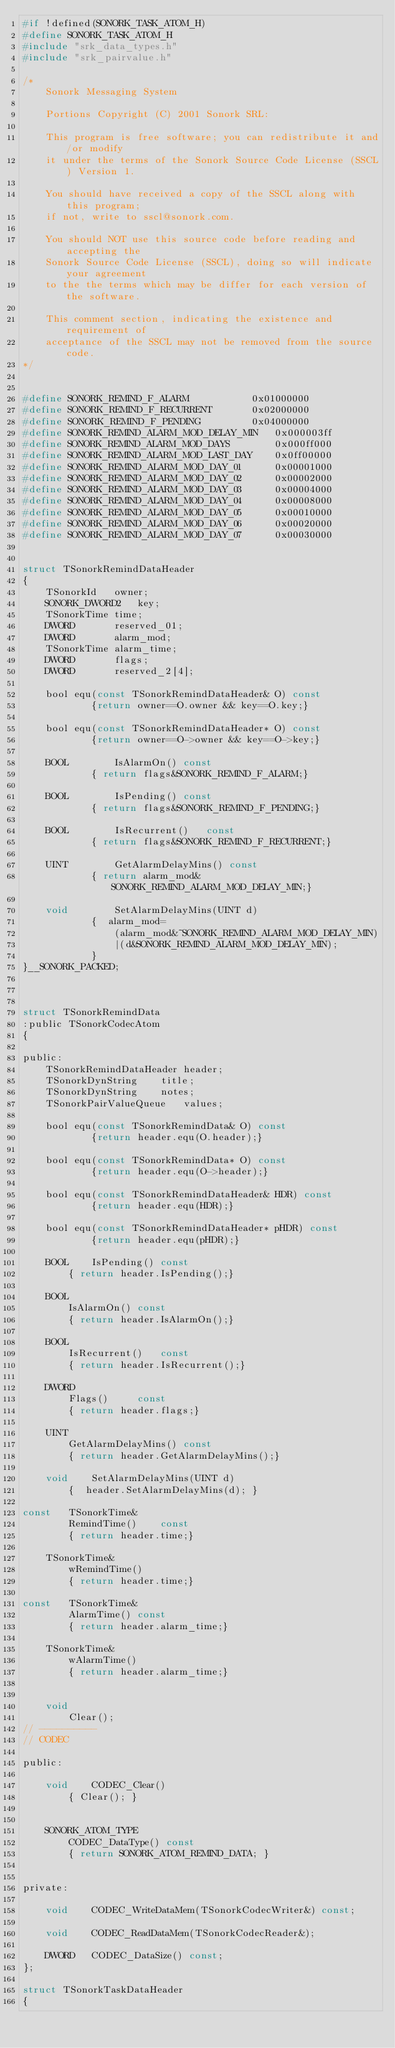Convert code to text. <code><loc_0><loc_0><loc_500><loc_500><_C_>#if !defined(SONORK_TASK_ATOM_H)
#define SONORK_TASK_ATOM_H
#include "srk_data_types.h"
#include "srk_pairvalue.h"

/*
	Sonork Messaging System

	Portions Copyright (C) 2001 Sonork SRL:

	This program is free software; you can redistribute it and/or modify
	it under the terms of the Sonork Source Code License (SSCL) Version 1.

	You should have received a copy of the SSCL	along with this program;
	if not, write to sscl@sonork.com.

	You should NOT use this source code before reading and accepting the
	Sonork Source Code License (SSCL), doing so will indicate your agreement
	to the the terms which may be differ for each version of the software.

	This comment section, indicating the existence and requirement of
	acceptance of the SSCL may not be removed from the source code.
*/


#define SONORK_REMIND_F_ALARM			0x01000000
#define SONORK_REMIND_F_RECURRENT		0x02000000
#define SONORK_REMIND_F_PENDING			0x04000000
#define SONORK_REMIND_ALARM_MOD_DELAY_MIN	0x000003ff
#define SONORK_REMIND_ALARM_MOD_DAYS   		0x000ff000
#define SONORK_REMIND_ALARM_MOD_LAST_DAY	0x0ff00000
#define SONORK_REMIND_ALARM_MOD_DAY_01		0x00001000
#define SONORK_REMIND_ALARM_MOD_DAY_02		0x00002000
#define SONORK_REMIND_ALARM_MOD_DAY_03		0x00004000
#define SONORK_REMIND_ALARM_MOD_DAY_04		0x00008000
#define SONORK_REMIND_ALARM_MOD_DAY_05		0x00010000
#define SONORK_REMIND_ALARM_MOD_DAY_06		0x00020000
#define SONORK_REMIND_ALARM_MOD_DAY_07		0x00030000


struct TSonorkRemindDataHeader
{
	TSonorkId	owner;
	SONORK_DWORD2	key;
	TSonorkTime	time;
	DWORD		reserved_01;
	DWORD		alarm_mod;
	TSonorkTime	alarm_time;
	DWORD		flags;
	DWORD		reserved_2[4];

	bool equ(const TSonorkRemindDataHeader& O) const
			{return owner==O.owner && key==O.key;}

	bool equ(const TSonorkRemindDataHeader* O) const
			{return owner==O->owner && key==O->key;}

	BOOL		IsAlarmOn()	const
			{ return flags&SONORK_REMIND_F_ALARM;}

	BOOL		IsPending()	const
			{ return flags&SONORK_REMIND_F_PENDING;}

	BOOL		IsRecurrent()	const
			{ return flags&SONORK_REMIND_F_RECURRENT;}

	UINT		GetAlarmDelayMins()	const
			{ return alarm_mod&SONORK_REMIND_ALARM_MOD_DELAY_MIN;}

	void		SetAlarmDelayMins(UINT d)
			{  alarm_mod=
				(alarm_mod&~SONORK_REMIND_ALARM_MOD_DELAY_MIN)
				|(d&SONORK_REMIND_ALARM_MOD_DELAY_MIN);
			}
}__SONORK_PACKED;



struct TSonorkRemindData
:public TSonorkCodecAtom
{

public:
	TSonorkRemindDataHeader	header;
	TSonorkDynString	title;
	TSonorkDynString	notes;
	TSonorkPairValueQueue 	values;

	bool equ(const TSonorkRemindData& O) const
			{return header.equ(O.header);}

	bool equ(const TSonorkRemindData* O) const
			{return header.equ(O->header);}

	bool equ(const TSonorkRemindDataHeader& HDR) const
			{return header.equ(HDR);}

	bool equ(const TSonorkRemindDataHeader* pHDR) const
			{return header.equ(pHDR);}

	BOOL	IsPending()	const
		{ return header.IsPending();}

	BOOL
		IsAlarmOn()	const
		{ return header.IsAlarmOn();}

	BOOL
		IsRecurrent()	const
		{ return header.IsRecurrent();}

	DWORD
		Flags() 	const
		{ return header.flags;}

	UINT
		GetAlarmDelayMins()	const
		{ return header.GetAlarmDelayMins();}

	void	SetAlarmDelayMins(UINT d)
		{  header.SetAlarmDelayMins(d);	}

const	TSonorkTime&
		RemindTime()	const
		{ return header.time;}

	TSonorkTime&
		wRemindTime()
		{ return header.time;}

const	TSonorkTime&
		AlarmTime() const
		{ return header.alarm_time;}

	TSonorkTime&
		wAlarmTime()
		{ return header.alarm_time;}


	void
		Clear();
// ----------
// CODEC

public:

	void 	CODEC_Clear()
		{ Clear(); }

	SONORK_ATOM_TYPE
		CODEC_DataType() const
		{ return SONORK_ATOM_REMIND_DATA; }

private:

	void	CODEC_WriteDataMem(TSonorkCodecWriter&) const;

	void	CODEC_ReadDataMem(TSonorkCodecReader&);

	DWORD	CODEC_DataSize() const;
};

struct TSonorkTaskDataHeader
{</code> 